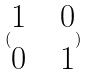Convert formula to latex. <formula><loc_0><loc_0><loc_500><loc_500>( \begin{matrix} 1 & & 0 \\ 0 & & 1 \end{matrix} )</formula> 